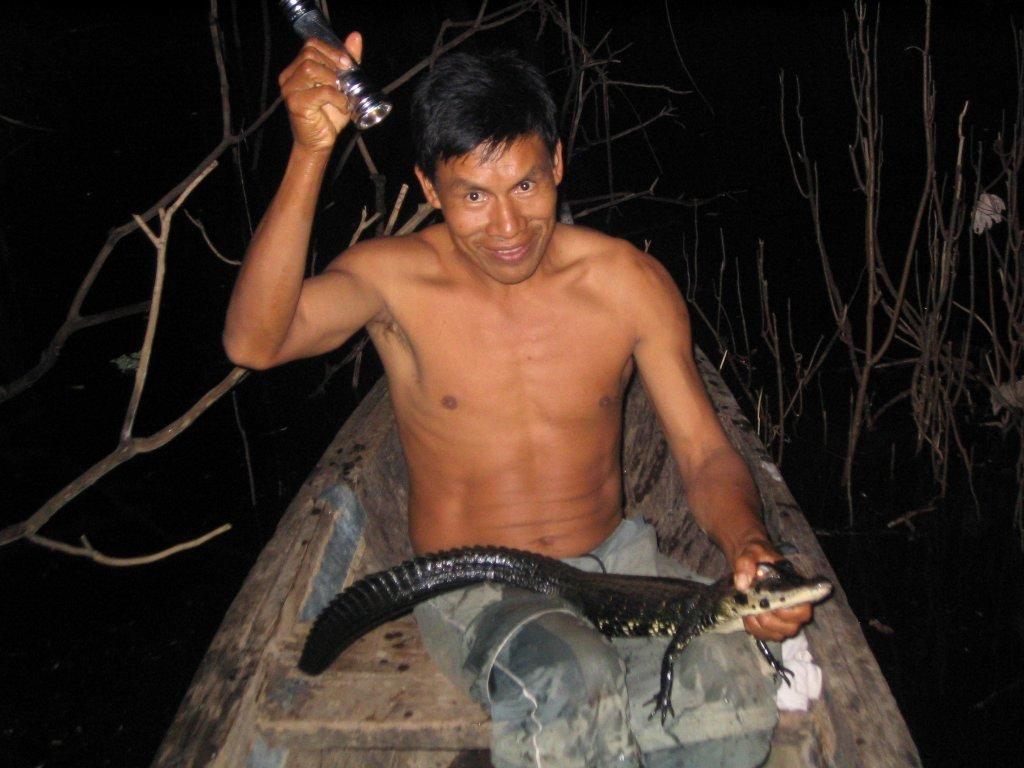What is the person in the image doing? The person is holding an animal. What else is the person holding in the image? The person is holding something else. Can you describe the background of the image? The background of the image is black, and there are dry stems visible. What type of bread can be seen in the image? There is no bread present in the image. Can you describe the eggnog in the image? There is no eggnog present in the image. 